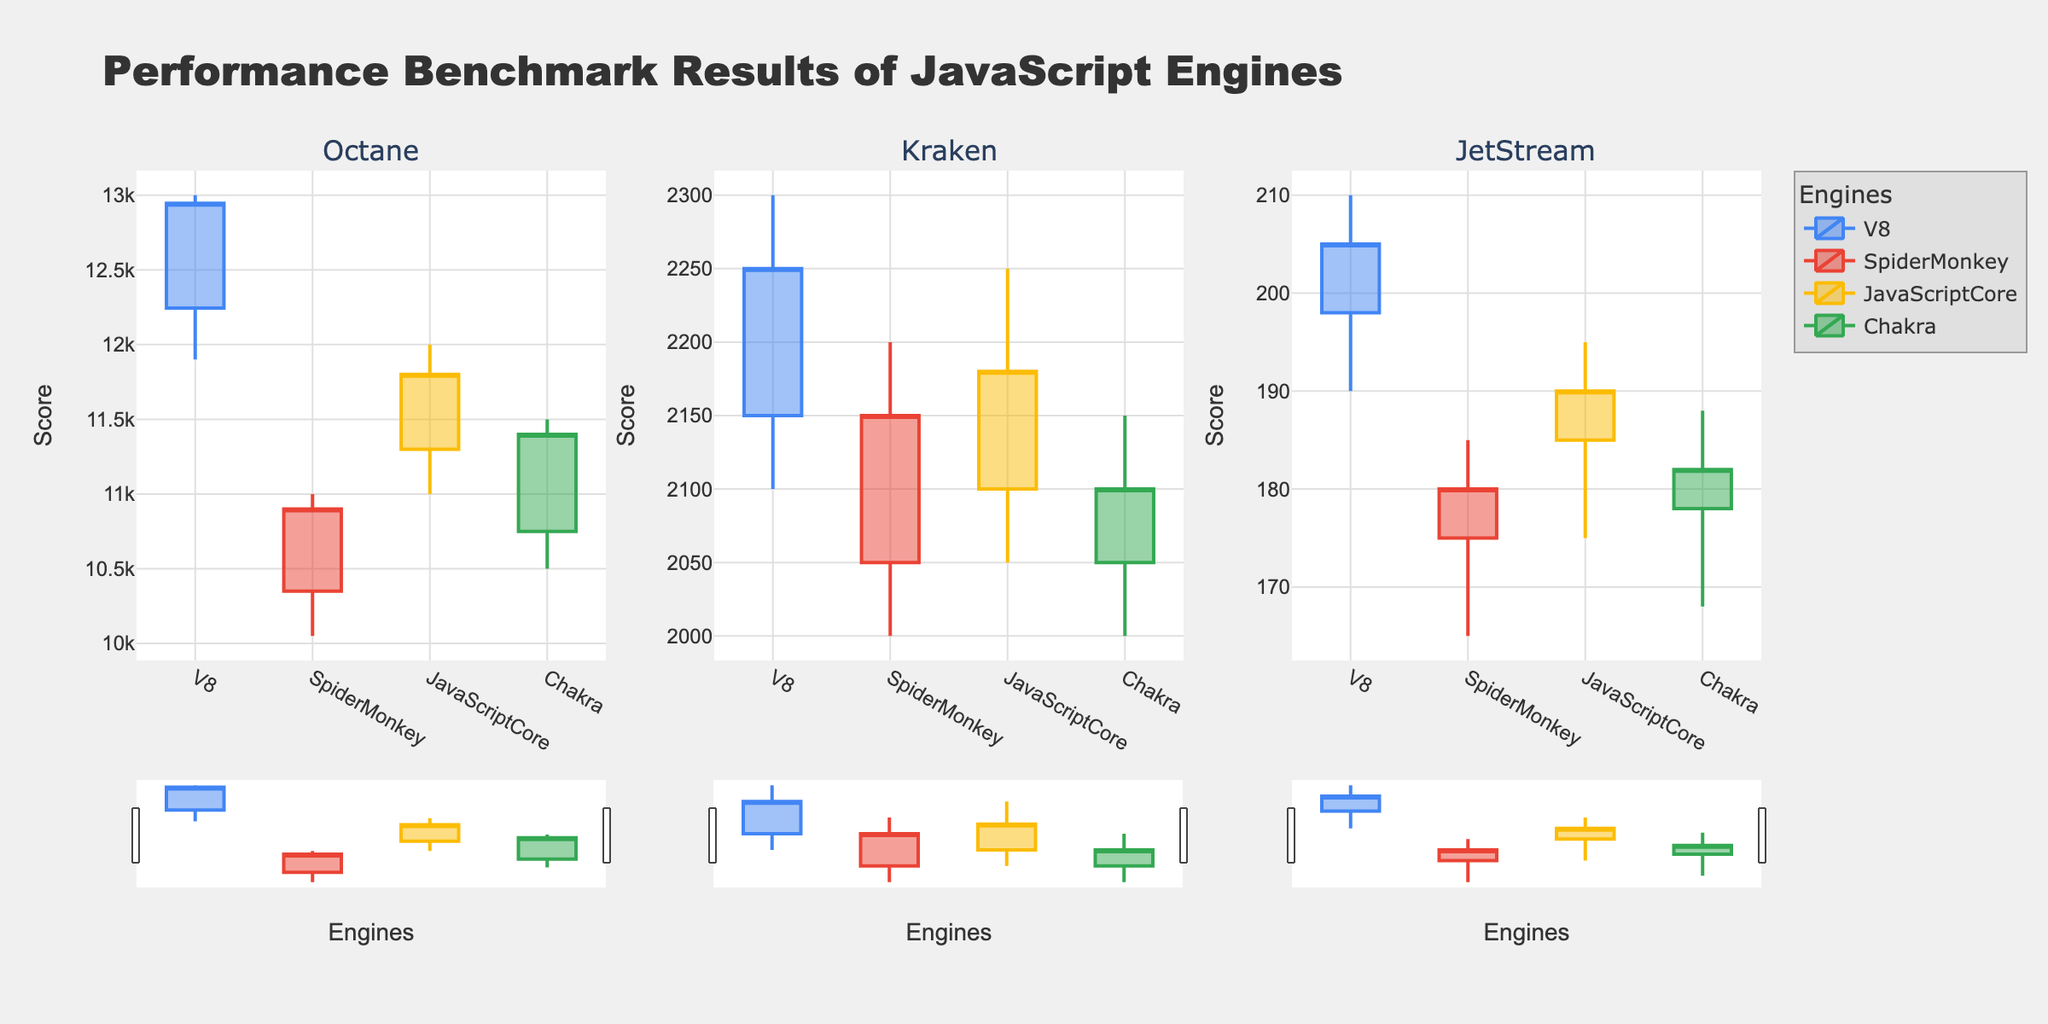What is the title of the figure? The title of the figure is provided at the top. It reads: "Performance Benchmark Results of JavaScript Engines".
Answer: Performance Benchmark Results of JavaScript Engines Which test suite has the highest score for the V8 engine? Look at the V8 candlesticks in each test suite (Octane, Kraken, JetStream). The highest score is the highest high value. For V8, the high values are 13000 (Octane), 2300 (Kraken), and 210 (JetStream).
Answer: Octane How do JavaScriptCore and Chakra engines compare in Kraken? Compare the open, high, low, and close values of JavaScriptCore and Chakra in the Kraken test suite. JavaScriptCore: Open=2100, High=2250, Low=2050, Close=2180; Chakra: Open=2050, High=2150, Low=2000, Close=2100.
Answer: JavaScriptCore has higher values in all metrics except open What is the range of scores for SpiderMonkey in JetStream? The range can be calculated by subtracting the low value from the high value. For SpiderMonkey in JetStream, the high is 185 and the low is 165. So, the range is 185 - 165.
Answer: 20 Which engine shows the most consistent performance in the Octane test suite? Consistency can be inferred by the difference between high and low values. Check the range (high - low) for each engine in Octane. V8: 13000 - 11900 = 1100, SpiderMonkey: 11000 - 10050 = 950, JavaScriptCore: 12000 - 11000 = 1000, Chakra: 11500 - 10500 = 1000.
Answer: SpiderMonkey What is the average closing score of the engines in the Kraken test suite? The closing scores for Kraken are V8: 2250, SpiderMonkey: 2150, JavaScriptCore: 2180, and Chakra: 2100. Average closing score = (2250 + 2150 + 2180 + 2100)/4.
Answer: 2170 Which engine has the lowest low value across all test suites? Find the lowest value for each engine across all test suites: V8: 190 (JetStream), SpiderMonkey: 165 (JetStream), JavaScriptCore: 175 (JetStream), Chakra: 168 (JetStream). The lowest among these is 165 for SpiderMonkey.
Answer: SpiderMonkey What is the median high value for all engines in the Octane test suite? High values in Octane for all engines: V8: 13000, SpiderMonkey: 11000, JavaScriptCore: 12000, Chakra: 11500. Ordered: 11000, 11500, 12000, 13000. The median is the average of the two middle values, (11500 + 12000)/2.
Answer: 11750 If an engine's performance score is above its open value but below its high value, what can we infer about its performance in that test suite? This indicates performance improvement but not optimal as it didn't reach the maximum potential. In candlestick terms, it means the engine performed better than the start (open) but didn't hit the highest score recorded (high).
Answer: Improved but not optimal 